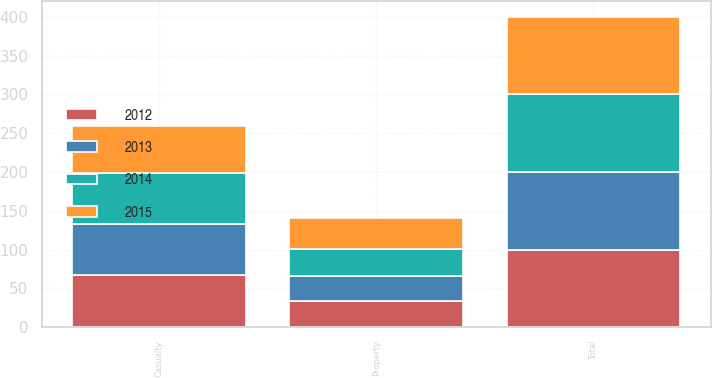<chart> <loc_0><loc_0><loc_500><loc_500><stacked_bar_chart><ecel><fcel>Casualty<fcel>Property<fcel>Total<nl><fcel>2015<fcel>59.7<fcel>40.3<fcel>100<nl><fcel>2012<fcel>66.7<fcel>33.3<fcel>100<nl><fcel>2013<fcel>66.9<fcel>33.1<fcel>100<nl><fcel>2014<fcel>65.6<fcel>34.4<fcel>100<nl></chart> 